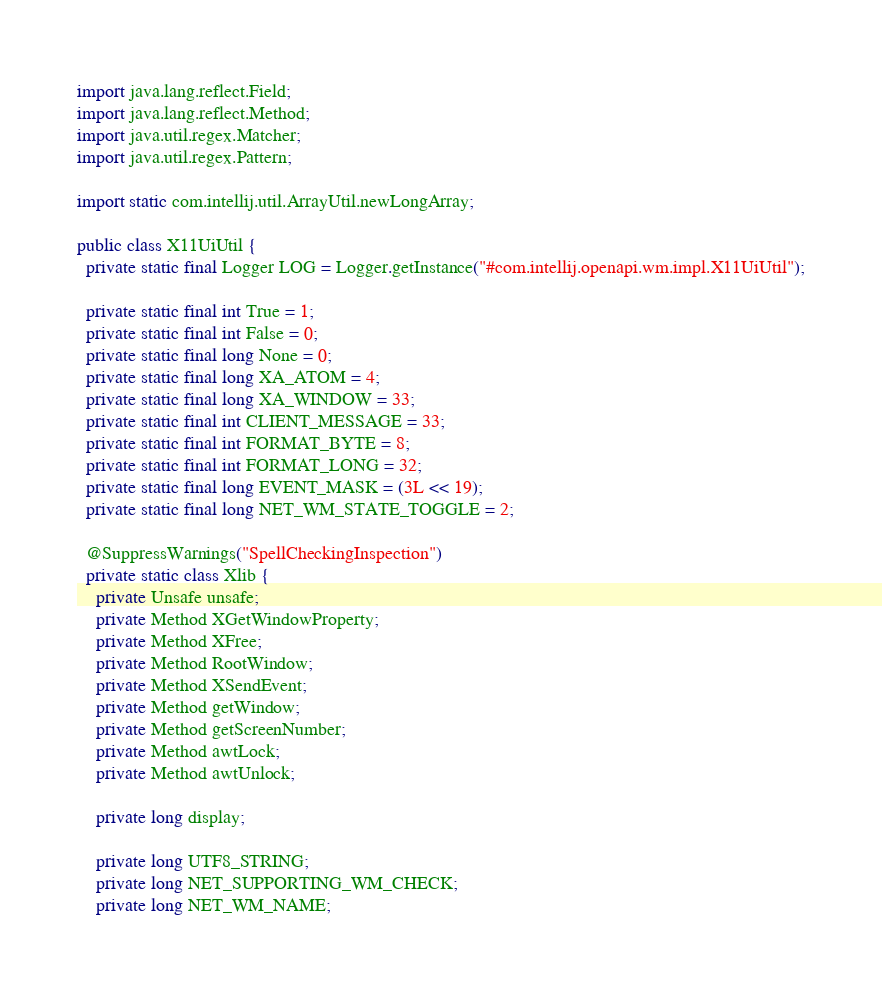<code> <loc_0><loc_0><loc_500><loc_500><_Java_>import java.lang.reflect.Field;
import java.lang.reflect.Method;
import java.util.regex.Matcher;
import java.util.regex.Pattern;

import static com.intellij.util.ArrayUtil.newLongArray;

public class X11UiUtil {
  private static final Logger LOG = Logger.getInstance("#com.intellij.openapi.wm.impl.X11UiUtil");

  private static final int True = 1;
  private static final int False = 0;
  private static final long None = 0;
  private static final long XA_ATOM = 4;
  private static final long XA_WINDOW = 33;
  private static final int CLIENT_MESSAGE = 33;
  private static final int FORMAT_BYTE = 8;
  private static final int FORMAT_LONG = 32;
  private static final long EVENT_MASK = (3L << 19);
  private static final long NET_WM_STATE_TOGGLE = 2;

  @SuppressWarnings("SpellCheckingInspection")
  private static class Xlib {
    private Unsafe unsafe;
    private Method XGetWindowProperty;
    private Method XFree;
    private Method RootWindow;
    private Method XSendEvent;
    private Method getWindow;
    private Method getScreenNumber;
    private Method awtLock;
    private Method awtUnlock;

    private long display;

    private long UTF8_STRING;
    private long NET_SUPPORTING_WM_CHECK;
    private long NET_WM_NAME;</code> 